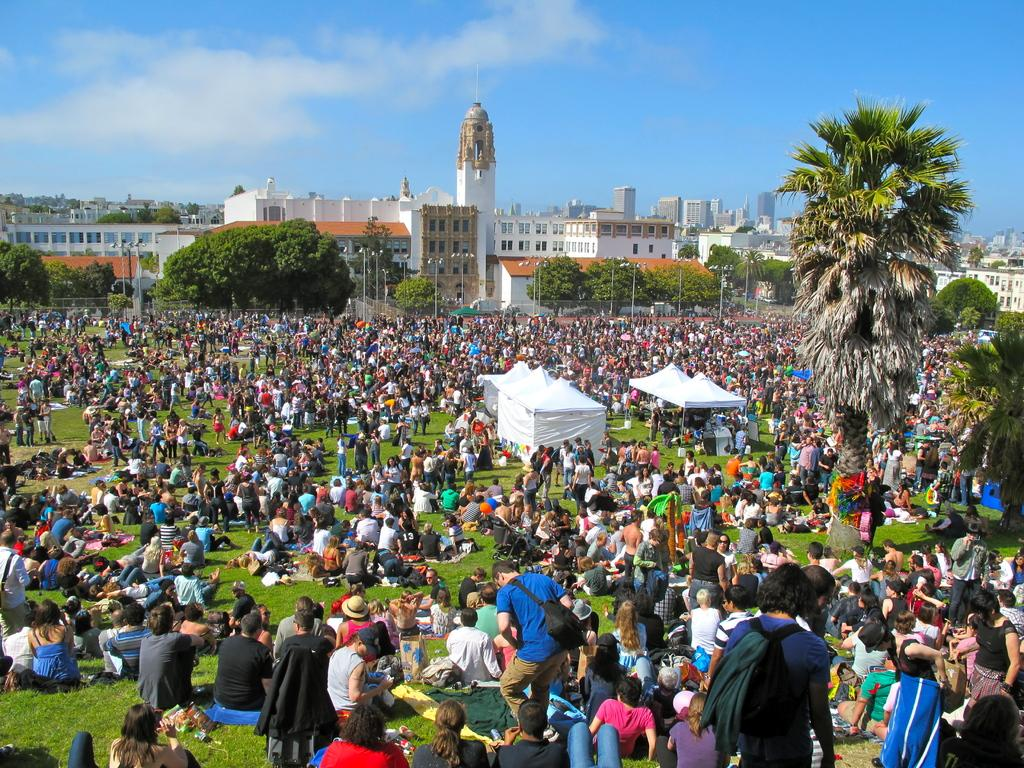What are the people in the image doing? There is a group of people sitting on grass in the image. What structures can be seen in the image? There are tents and buildings in the image. What type of vegetation is present in the image? There are trees in the image. What can be seen in the background of the image? The sky is visible in the background of the image, and clouds are present in the sky. What type of lawyer is sitting on the grass in the image? There is no lawyer present in the image; it features a group of people sitting on grass. Can you tell me how many pieces of quartz are visible in the image? There is no quartz present in the image. 